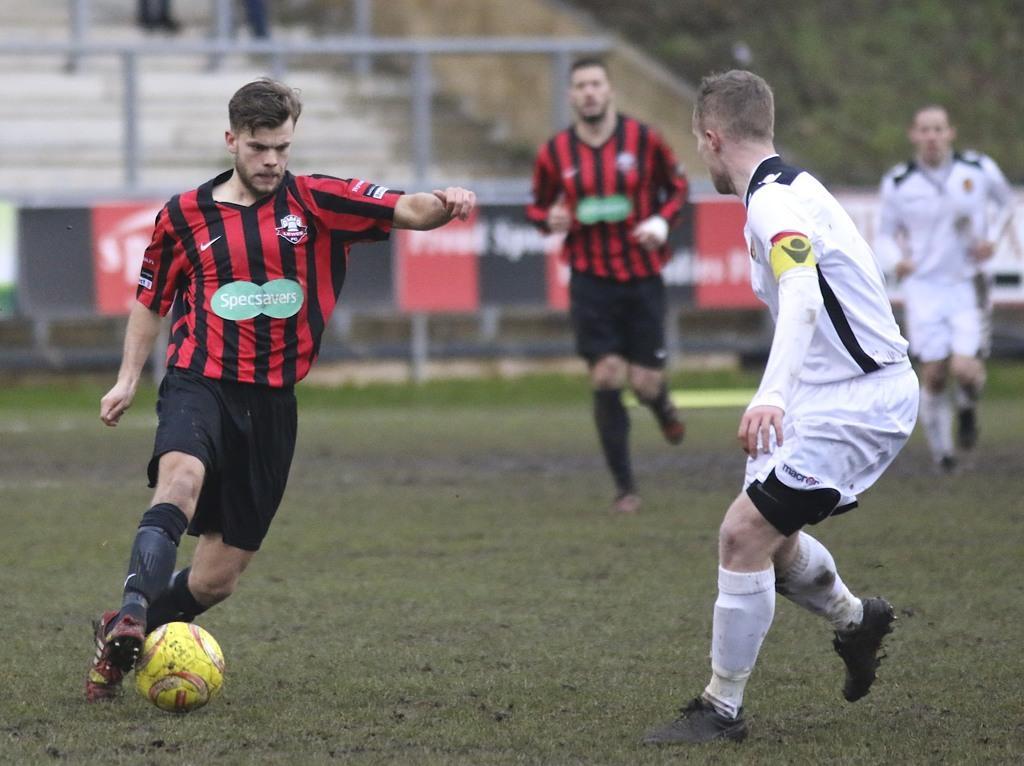Please provide a concise description of this image. There are a four people who are a playing a football on the football ground. 